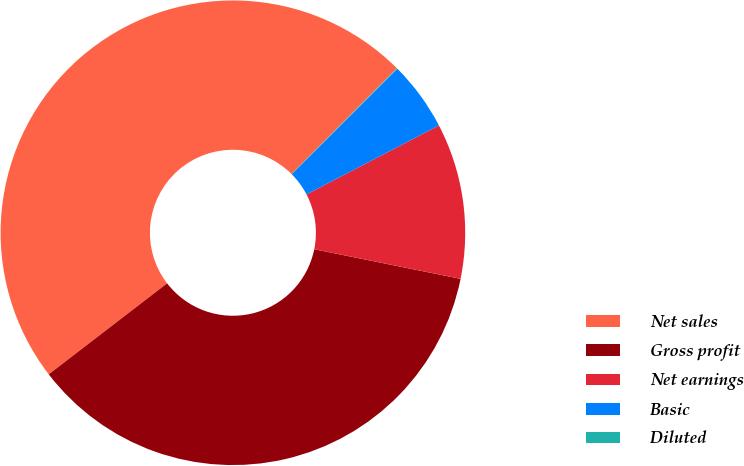Convert chart. <chart><loc_0><loc_0><loc_500><loc_500><pie_chart><fcel>Net sales<fcel>Gross profit<fcel>Net earnings<fcel>Basic<fcel>Diluted<nl><fcel>47.91%<fcel>36.39%<fcel>10.82%<fcel>4.83%<fcel>0.05%<nl></chart> 